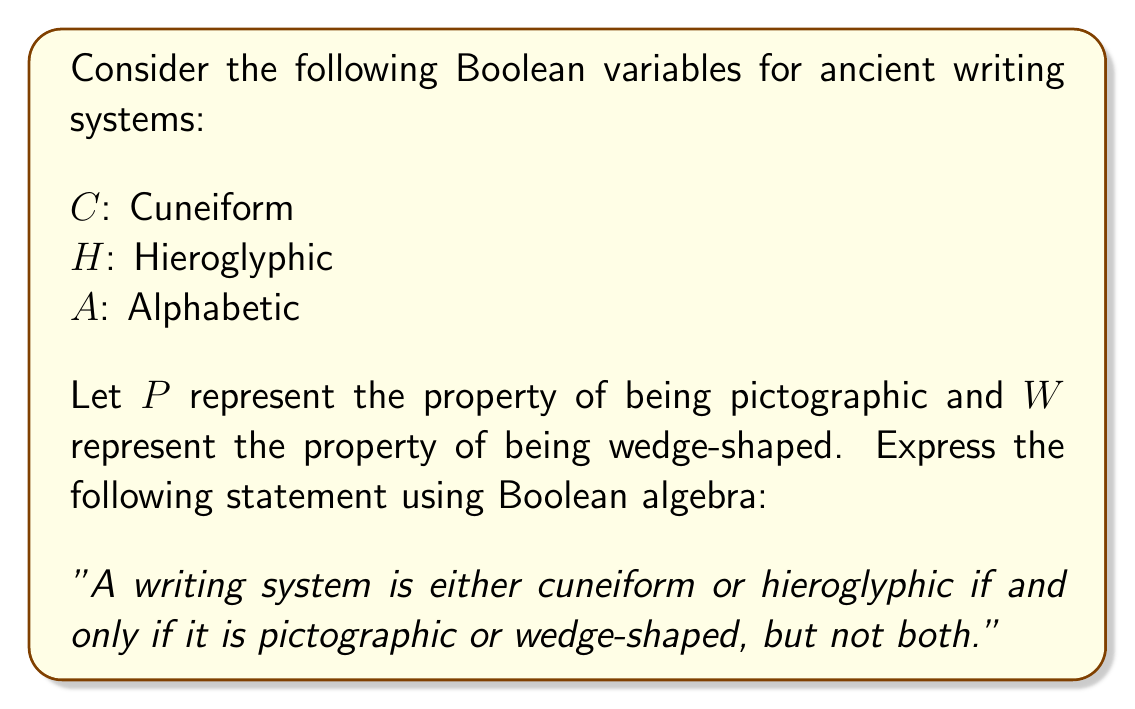Provide a solution to this math problem. Let's break this down step-by-step:

1) First, we need to express "cuneiform or hieroglyphic" in Boolean algebra:
   $C \lor H$

2) Next, we need to express "pictographic or wedge-shaped, but not both":
   This is an exclusive OR (XOR) operation, which can be written as:
   $(P \lor W) \land \lnot(P \land W)$

3) The statement says that these two expressions are equivalent ("if and only if"), which we represent with the symbol $\leftrightarrow$

4) Therefore, the complete Boolean expression is:
   $(C \lor H) \leftrightarrow [(P \lor W) \land \lnot(P \land W)]$

5) We can simplify the right side of the expression using the XOR symbol $\oplus$:
   $(C \lor H) \leftrightarrow (P \oplus W)$

This Boolean expression accurately represents the given statement, classifying ancient writing systems based on their characteristics of being cuneiform/hieroglyphic and pictographic/wedge-shaped.
Answer: $(C \lor H) \leftrightarrow (P \oplus W)$ 